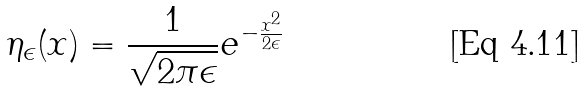Convert formula to latex. <formula><loc_0><loc_0><loc_500><loc_500>\eta _ { \epsilon } ( x ) = \frac { 1 } { \sqrt { 2 \pi \epsilon } } e ^ { - \frac { x ^ { 2 } } { 2 \epsilon } }</formula> 